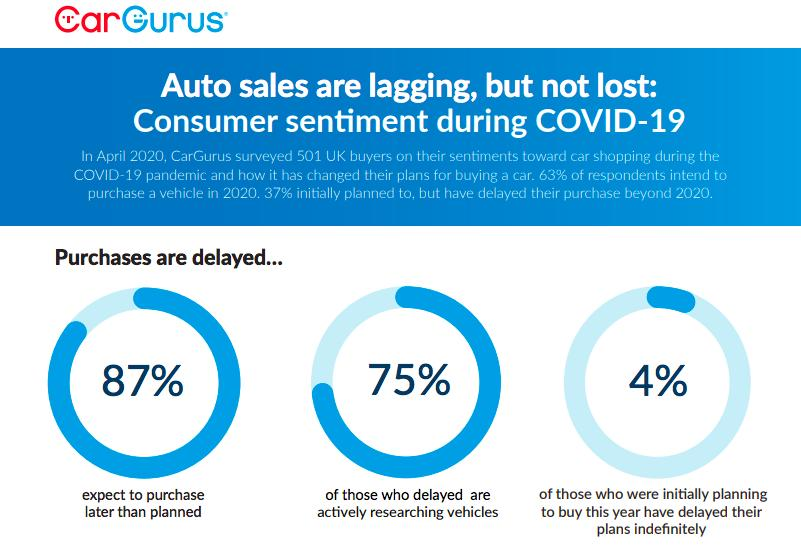Identify some key points in this picture. A recent survey has revealed that an overwhelming 87% of consumers expect to make a vehicle purchase later than originally planned. According to the given information, 4% of consumers have delayed their plans indefinitely. According to the survey, 75% of consumers who had previously delayed their vehicle purchase are now actively researching and considering their options. 